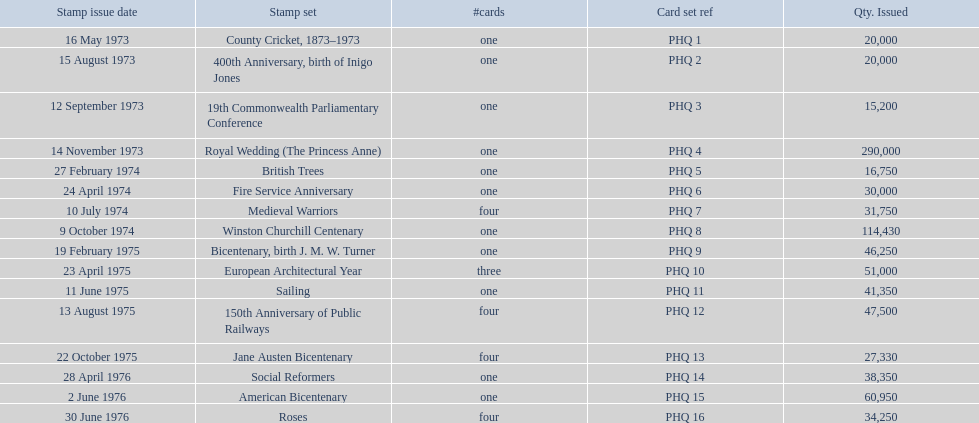Which stamp sets were issued? County Cricket, 1873–1973, 400th Anniversary, birth of Inigo Jones, 19th Commonwealth Parliamentary Conference, Royal Wedding (The Princess Anne), British Trees, Fire Service Anniversary, Medieval Warriors, Winston Churchill Centenary, Bicentenary, birth J. M. W. Turner, European Architectural Year, Sailing, 150th Anniversary of Public Railways, Jane Austen Bicentenary, Social Reformers, American Bicentenary, Roses. Of those stamp sets, which had more that 200,000 issued? Royal Wedding (The Princess Anne). What are the stamp series in the phq? County Cricket, 1873–1973, 400th Anniversary, birth of Inigo Jones, 19th Commonwealth Parliamentary Conference, Royal Wedding (The Princess Anne), British Trees, Fire Service Anniversary, Medieval Warriors, Winston Churchill Centenary, Bicentenary, birth J. M. W. Turner, European Architectural Year, Sailing, 150th Anniversary of Public Railways, Jane Austen Bicentenary, Social Reformers, American Bicentenary, Roses. Which stamp series have a circulation surpassing 200,000? Royal Wedding (The Princess Anne). 